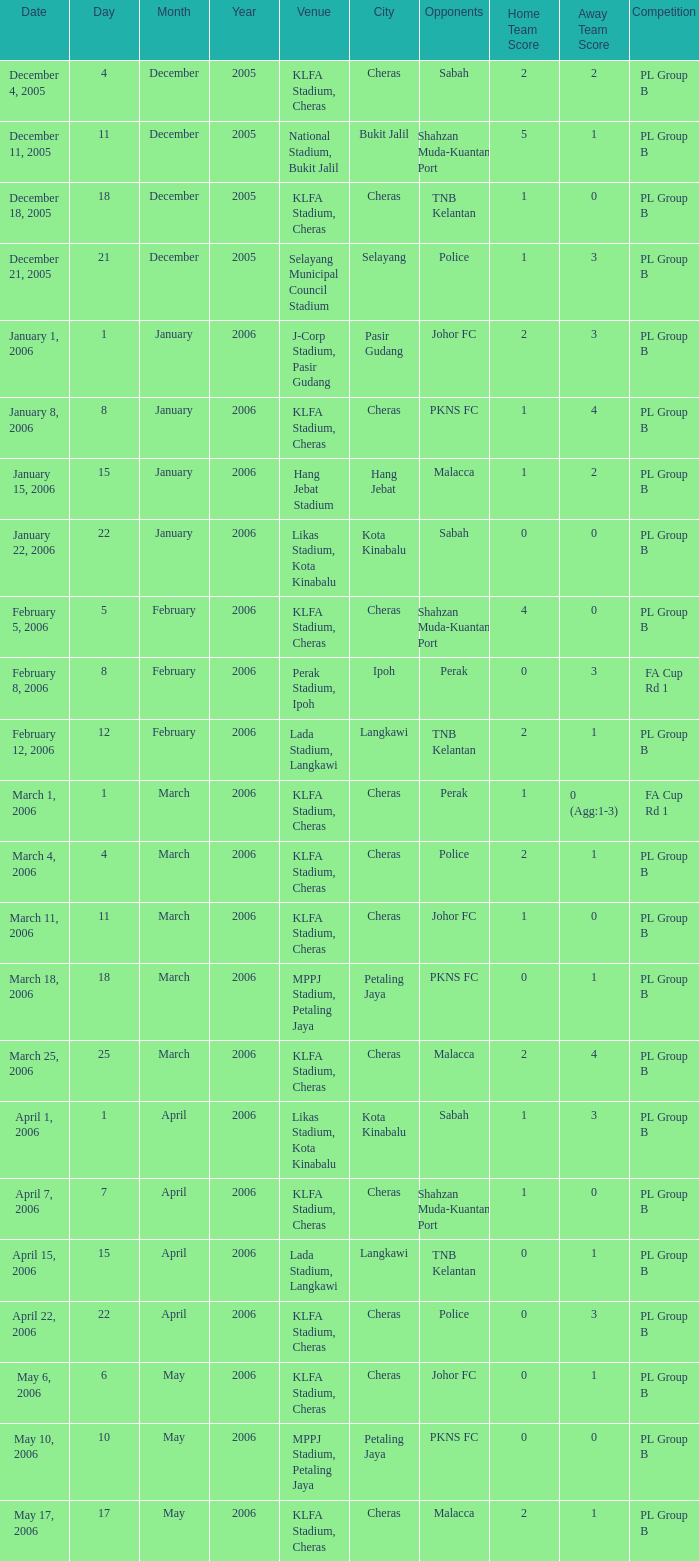Which Score has Opponents of pkns fc, and a Date of january 8, 2006? 1-4. 